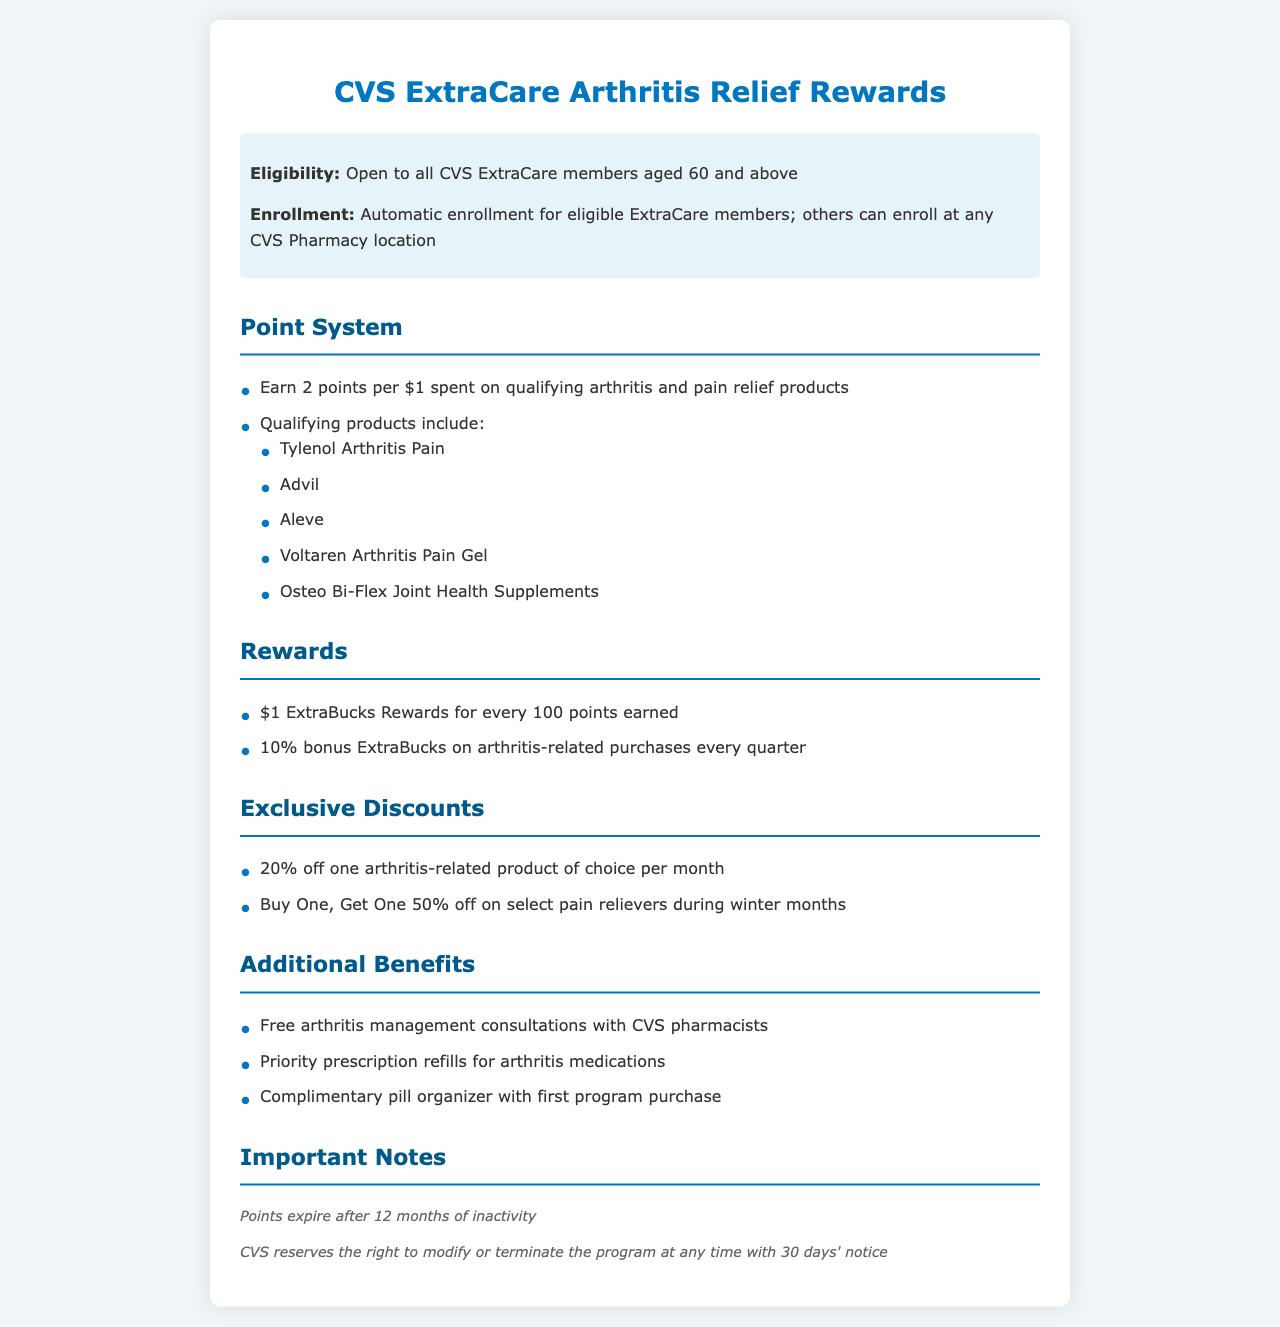What is the age eligibility for the program? The age eligibility for the program is stated as open to all CVS ExtraCare members aged 60 and above.
Answer: 60 How many points do you earn per dollar spent? The document specifies that you earn 2 points per $1 spent on qualifying arthritis and pain relief products.
Answer: 2 points What is the reward for every 100 points earned? The document states that you receive $1 ExtraBucks Rewards for every 100 points earned.
Answer: $1 How much discount is offered on one arthritis-related product each month? The document lists that there is a 20% off one arthritis-related product of choice per month.
Answer: 20% What bonus do you receive on arthritis-related purchases every quarter? The bonus specified in the document is 10% bonus ExtraBucks on arthritis-related purchases every quarter.
Answer: 10% What type of consultations are offered for free? The document mentions free arthritis management consultations with CVS pharmacists as part of the benefits.
Answer: Arthritis management consultations How long do points last without activity? According to the document, points expire after 12 months of inactivity.
Answer: 12 months What must you do to enroll if you are not an eligible member? The document states that others can enroll at any CVS Pharmacy location.
Answer: Enroll at any CVS Pharmacy location What is the policy on modifying or terminating the program? The document mentions that CVS reserves the right to modify or terminate the program at any time with 30 days' notice.
Answer: With 30 days' notice 